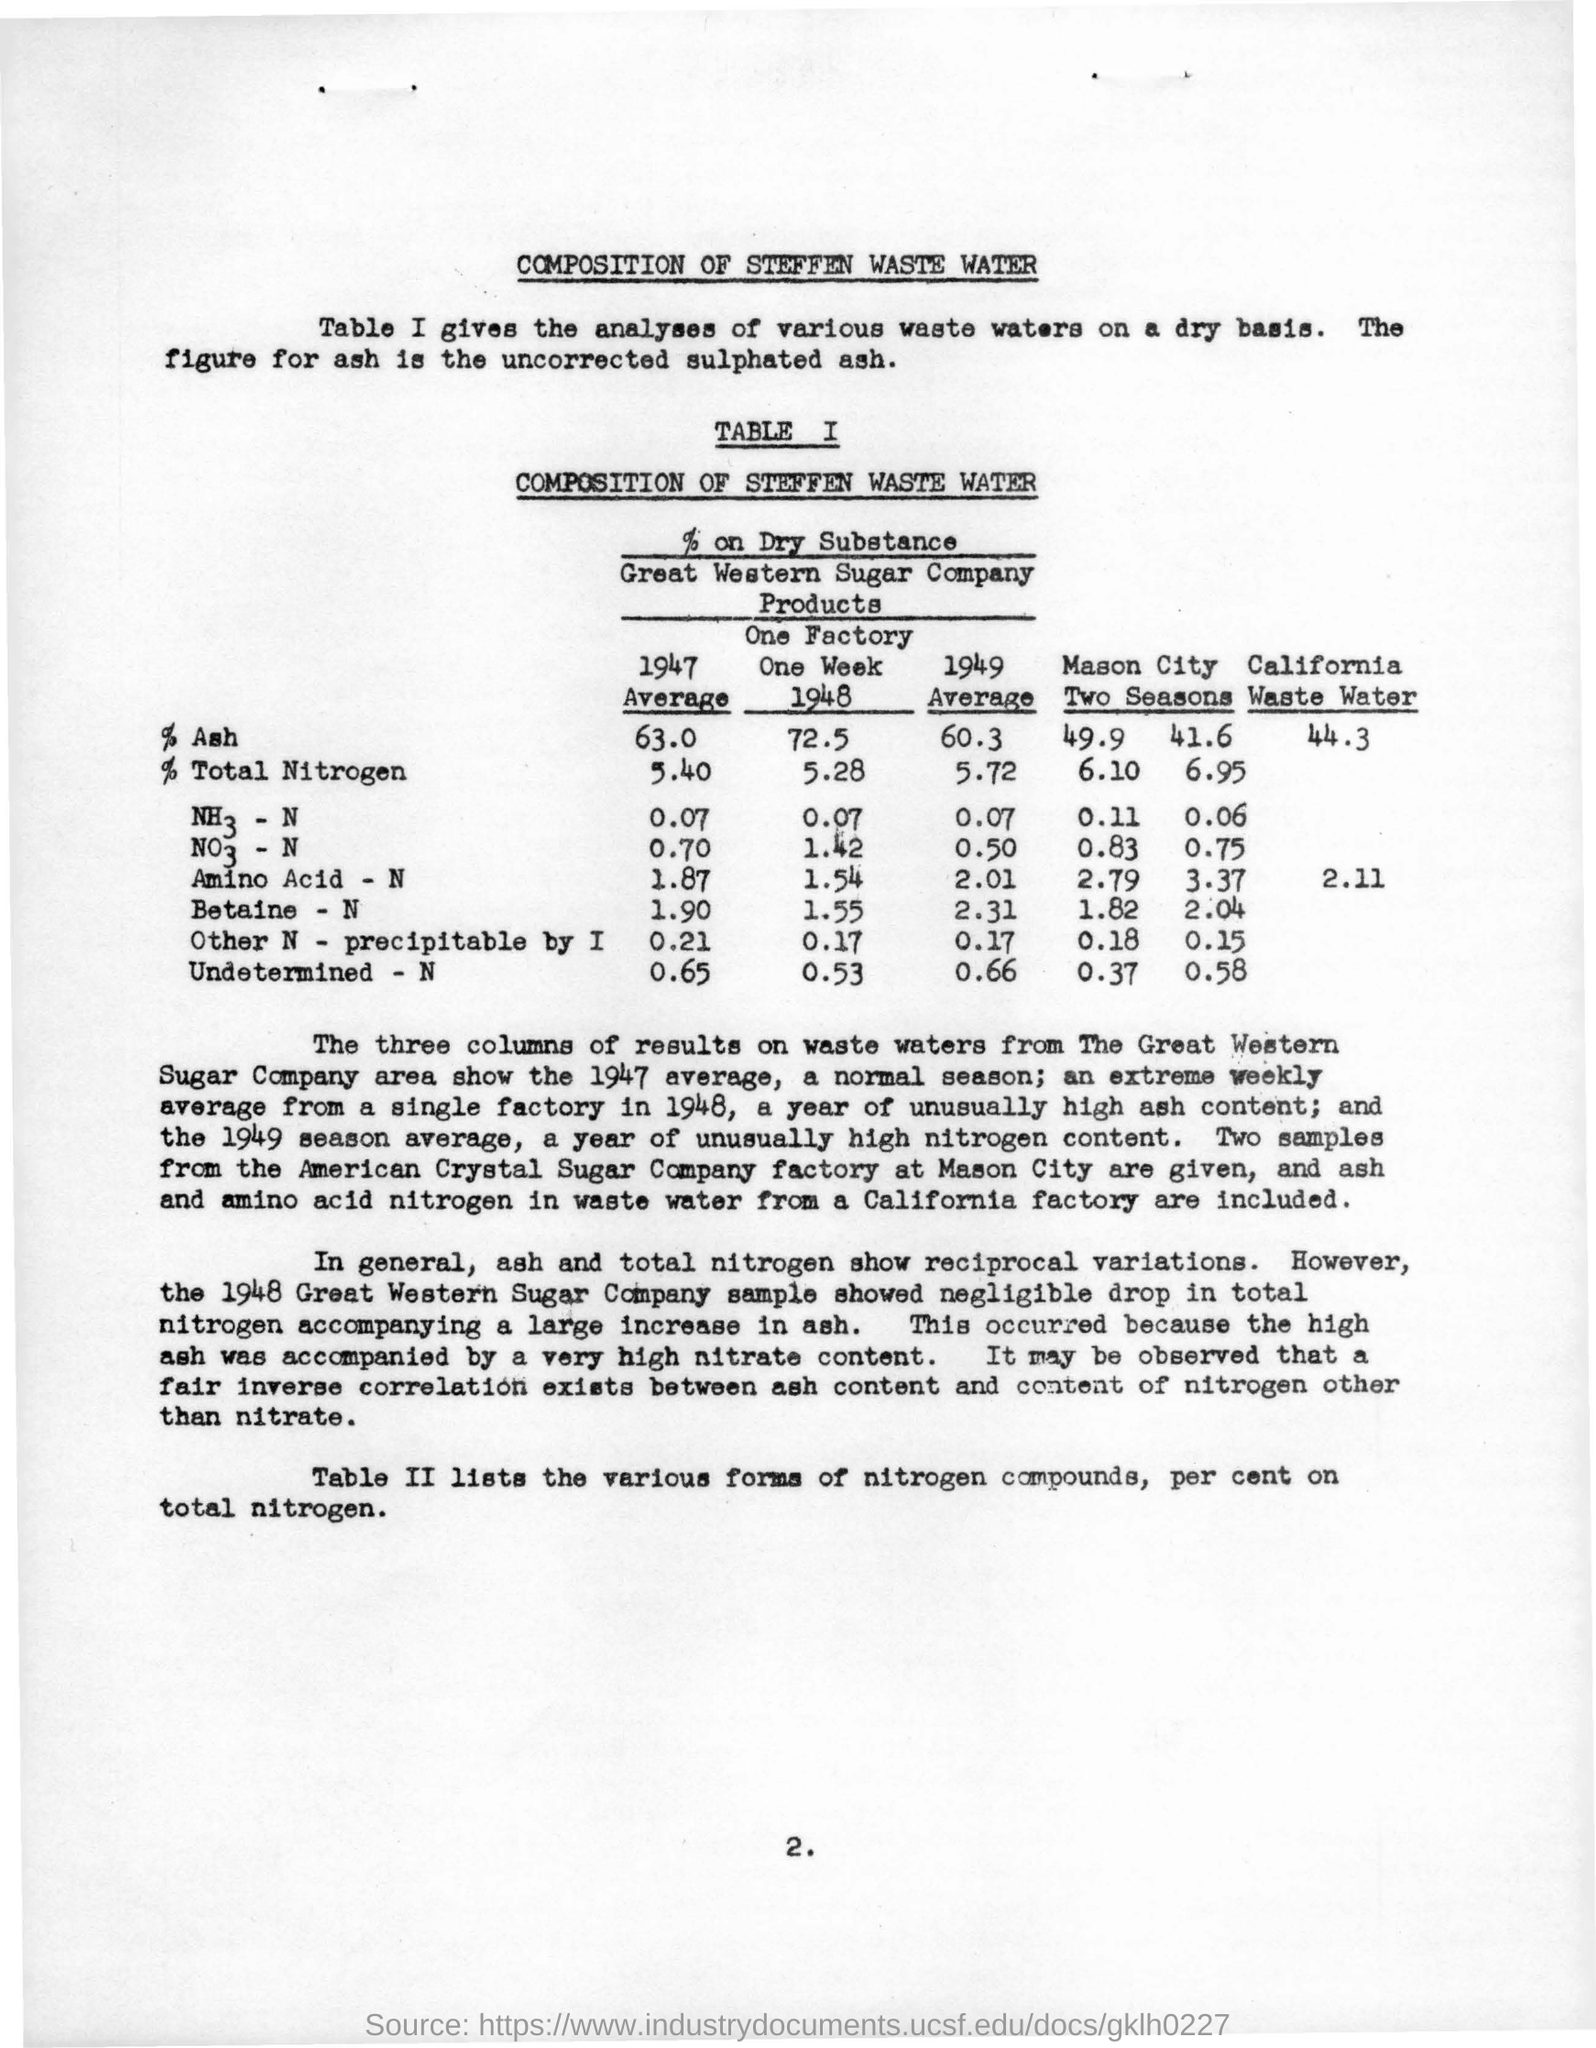What is the title of table I given here?
Your response must be concise. Composition of Steffen Waste Water. What is the average value of % of ash in the year 1949 ?
Ensure brevity in your answer.  60.3. What is the average value of % of total nitrogen in the year 1947 ?
Provide a succinct answer. 5.40. What is the name of the company ?
Your answer should be compact. Great Western Sugar Company. What is the value of amino acid -n in the year 1948 ?
Offer a terse response. 1.54. 